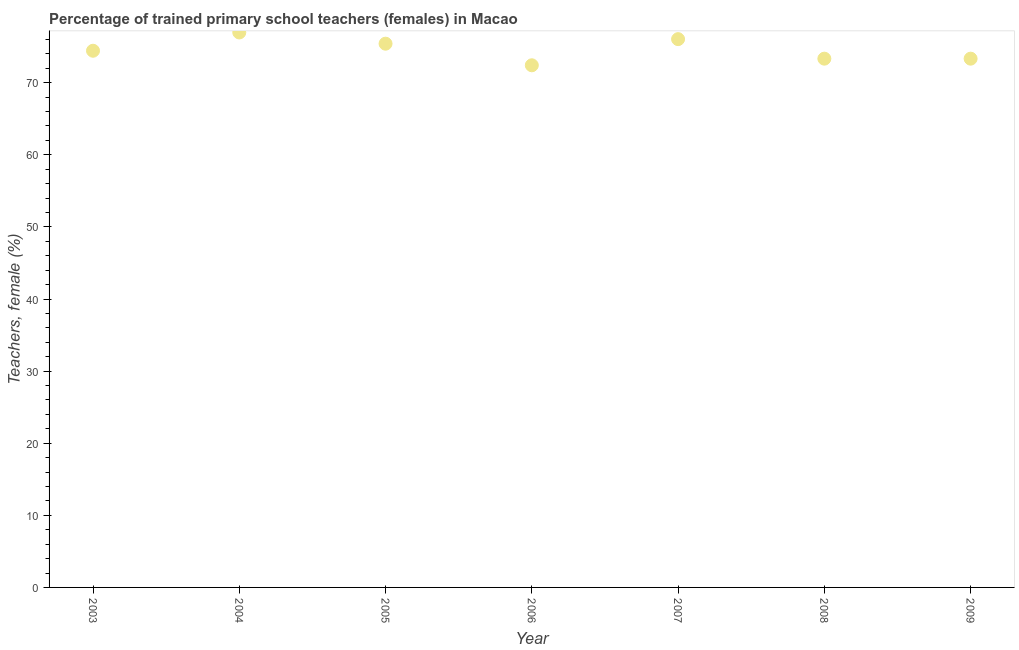What is the percentage of trained female teachers in 2008?
Keep it short and to the point. 73.33. Across all years, what is the maximum percentage of trained female teachers?
Offer a very short reply. 76.97. Across all years, what is the minimum percentage of trained female teachers?
Offer a very short reply. 72.41. In which year was the percentage of trained female teachers minimum?
Make the answer very short. 2006. What is the sum of the percentage of trained female teachers?
Ensure brevity in your answer.  521.93. What is the average percentage of trained female teachers per year?
Offer a very short reply. 74.56. What is the median percentage of trained female teachers?
Give a very brief answer. 74.43. What is the ratio of the percentage of trained female teachers in 2004 to that in 2009?
Your response must be concise. 1.05. What is the difference between the highest and the second highest percentage of trained female teachers?
Give a very brief answer. 0.92. What is the difference between the highest and the lowest percentage of trained female teachers?
Provide a succinct answer. 4.55. How many years are there in the graph?
Offer a very short reply. 7. What is the difference between two consecutive major ticks on the Y-axis?
Your answer should be very brief. 10. Does the graph contain grids?
Keep it short and to the point. No. What is the title of the graph?
Your answer should be very brief. Percentage of trained primary school teachers (females) in Macao. What is the label or title of the Y-axis?
Your answer should be compact. Teachers, female (%). What is the Teachers, female (%) in 2003?
Provide a succinct answer. 74.43. What is the Teachers, female (%) in 2004?
Keep it short and to the point. 76.97. What is the Teachers, female (%) in 2005?
Your answer should be compact. 75.41. What is the Teachers, female (%) in 2006?
Make the answer very short. 72.41. What is the Teachers, female (%) in 2007?
Ensure brevity in your answer.  76.04. What is the Teachers, female (%) in 2008?
Your answer should be very brief. 73.33. What is the Teachers, female (%) in 2009?
Ensure brevity in your answer.  73.33. What is the difference between the Teachers, female (%) in 2003 and 2004?
Your response must be concise. -2.53. What is the difference between the Teachers, female (%) in 2003 and 2005?
Your answer should be compact. -0.98. What is the difference between the Teachers, female (%) in 2003 and 2006?
Provide a short and direct response. 2.02. What is the difference between the Teachers, female (%) in 2003 and 2007?
Your response must be concise. -1.61. What is the difference between the Teachers, female (%) in 2003 and 2008?
Keep it short and to the point. 1.1. What is the difference between the Teachers, female (%) in 2003 and 2009?
Offer a very short reply. 1.1. What is the difference between the Teachers, female (%) in 2004 and 2005?
Your response must be concise. 1.56. What is the difference between the Teachers, female (%) in 2004 and 2006?
Give a very brief answer. 4.55. What is the difference between the Teachers, female (%) in 2004 and 2007?
Provide a succinct answer. 0.92. What is the difference between the Teachers, female (%) in 2004 and 2008?
Keep it short and to the point. 3.63. What is the difference between the Teachers, female (%) in 2004 and 2009?
Ensure brevity in your answer.  3.63. What is the difference between the Teachers, female (%) in 2005 and 2006?
Provide a succinct answer. 3. What is the difference between the Teachers, female (%) in 2005 and 2007?
Provide a succinct answer. -0.63. What is the difference between the Teachers, female (%) in 2005 and 2008?
Offer a terse response. 2.08. What is the difference between the Teachers, female (%) in 2005 and 2009?
Keep it short and to the point. 2.08. What is the difference between the Teachers, female (%) in 2006 and 2007?
Keep it short and to the point. -3.63. What is the difference between the Teachers, female (%) in 2006 and 2008?
Keep it short and to the point. -0.92. What is the difference between the Teachers, female (%) in 2006 and 2009?
Ensure brevity in your answer.  -0.92. What is the difference between the Teachers, female (%) in 2007 and 2008?
Your answer should be very brief. 2.71. What is the difference between the Teachers, female (%) in 2007 and 2009?
Your answer should be compact. 2.71. What is the difference between the Teachers, female (%) in 2008 and 2009?
Offer a terse response. 0. What is the ratio of the Teachers, female (%) in 2003 to that in 2004?
Give a very brief answer. 0.97. What is the ratio of the Teachers, female (%) in 2003 to that in 2006?
Keep it short and to the point. 1.03. What is the ratio of the Teachers, female (%) in 2003 to that in 2007?
Your answer should be compact. 0.98. What is the ratio of the Teachers, female (%) in 2004 to that in 2006?
Give a very brief answer. 1.06. What is the ratio of the Teachers, female (%) in 2004 to that in 2007?
Your response must be concise. 1.01. What is the ratio of the Teachers, female (%) in 2005 to that in 2006?
Give a very brief answer. 1.04. What is the ratio of the Teachers, female (%) in 2005 to that in 2007?
Your response must be concise. 0.99. What is the ratio of the Teachers, female (%) in 2005 to that in 2008?
Your answer should be compact. 1.03. What is the ratio of the Teachers, female (%) in 2005 to that in 2009?
Offer a very short reply. 1.03. What is the ratio of the Teachers, female (%) in 2006 to that in 2007?
Provide a short and direct response. 0.95. What is the ratio of the Teachers, female (%) in 2006 to that in 2009?
Provide a succinct answer. 0.99. What is the ratio of the Teachers, female (%) in 2008 to that in 2009?
Your response must be concise. 1. 